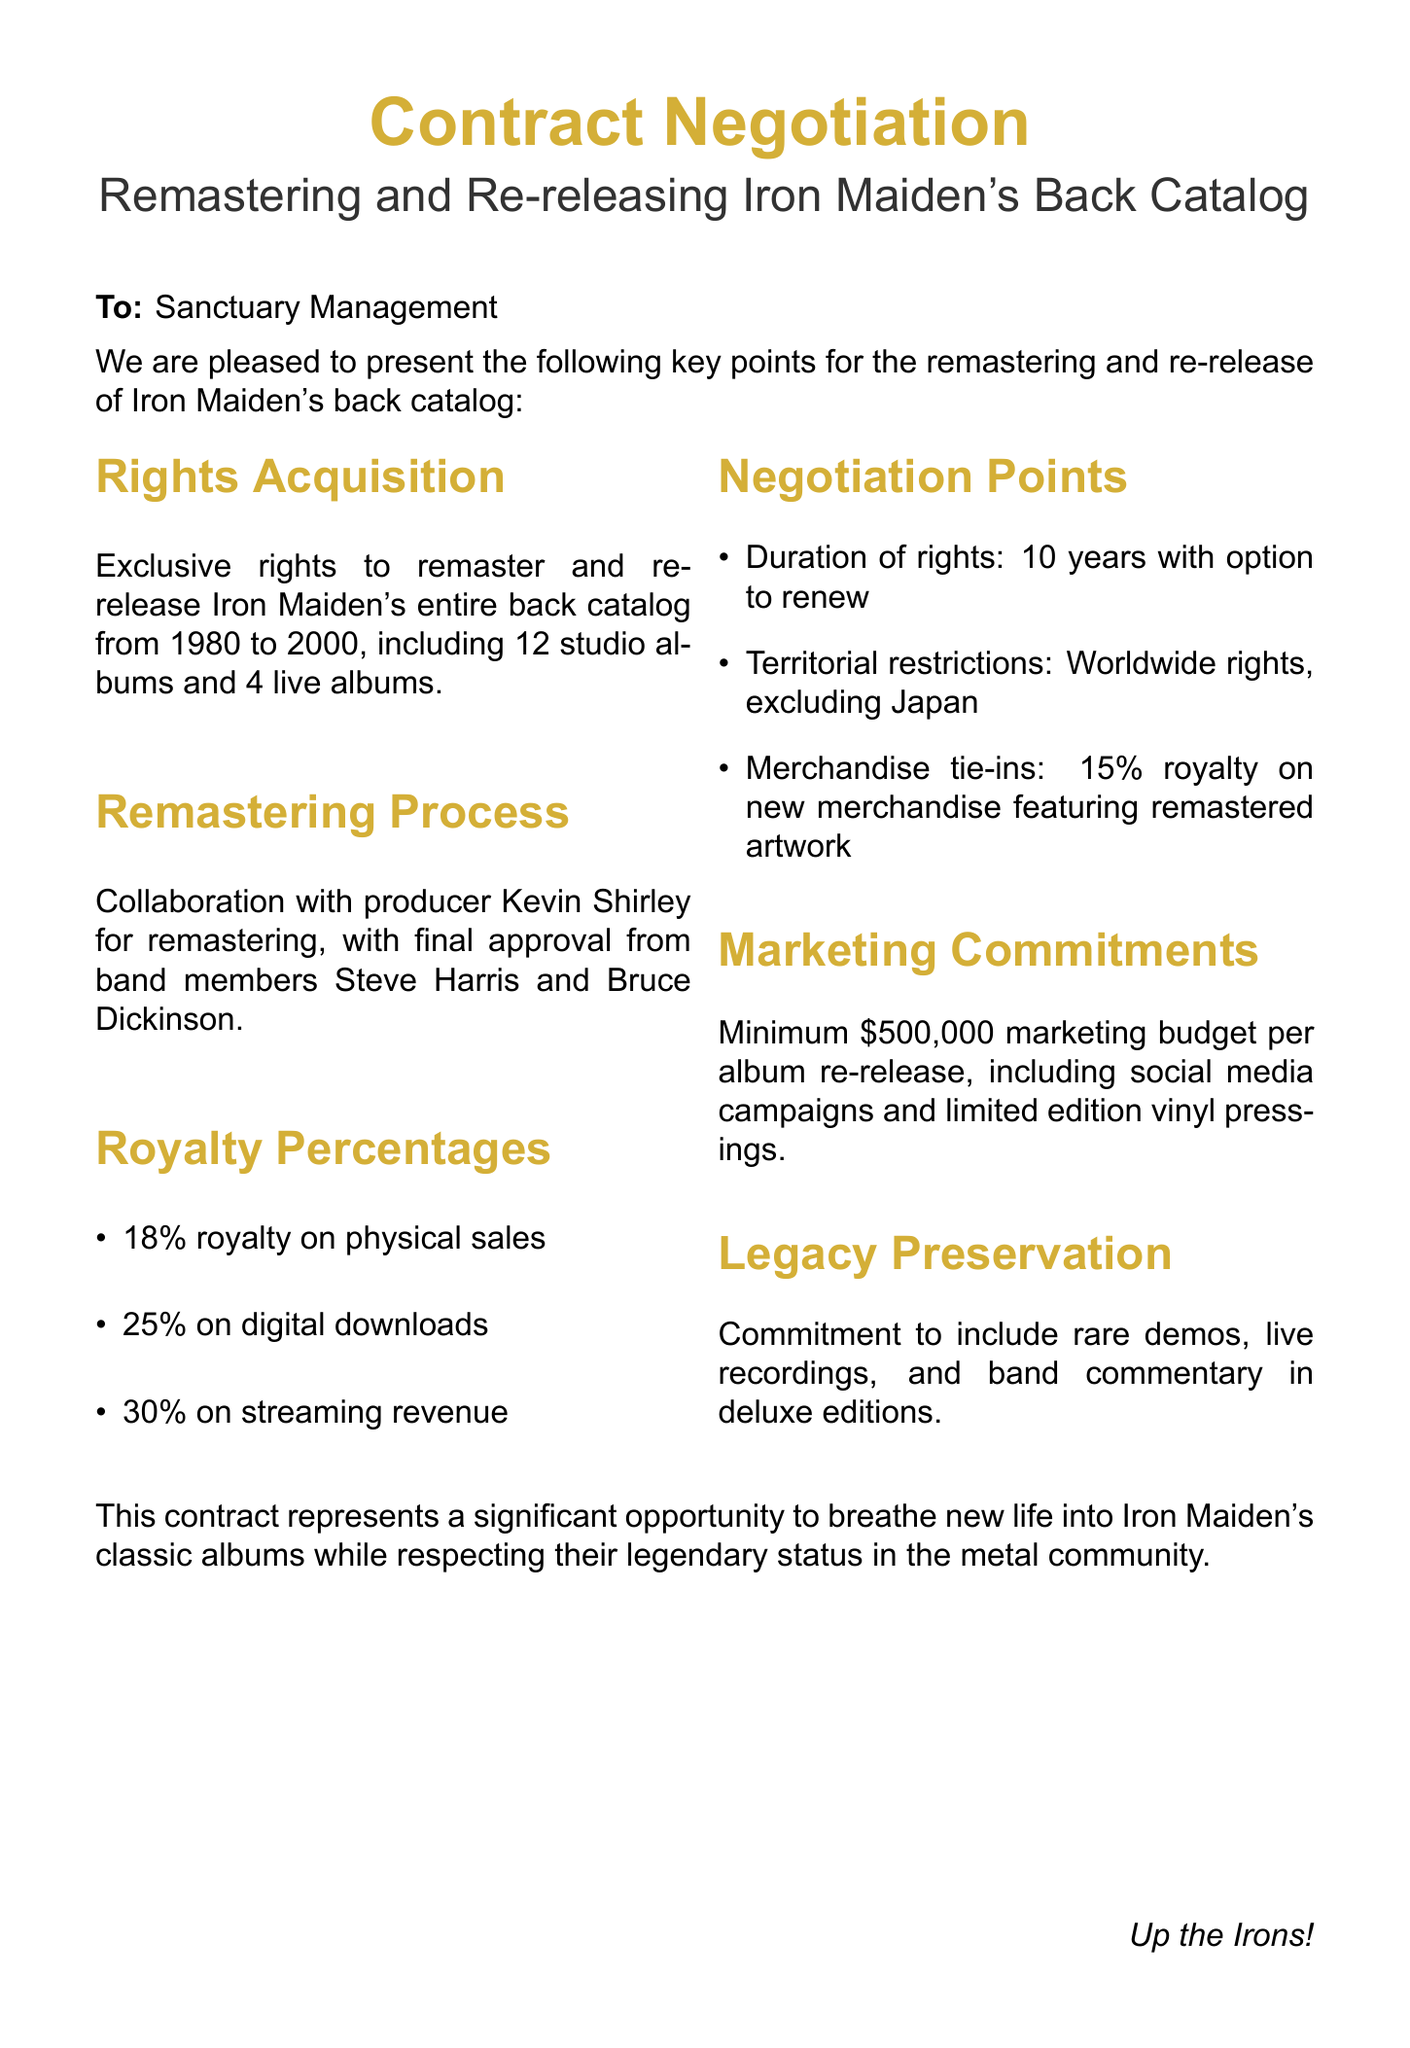What is the band name? The document specifies the band being discussed for rights acquisition.
Answer: Iron Maiden Who is the management company? The management company responsible for handling the contract is mentioned in the document.
Answer: Sanctuary Management How many studio albums are included? The document indicates the number of studio albums in the back catalog available for remastering.
Answer: 12 What is the royalty percentage on digital downloads? The royalty rates for different sales formats are outlined in the contract.
Answer: 25% What is the marketing budget per album re-release? The document specifies the minimum budget allocated for marketing each album re-release.
Answer: $500,000 What is the duration of rights according to the negotiation points? The duration of the rights to the music catalog is mentioned as part of the negotiation terms.
Answer: 10 years Are there any territorial restrictions? The document outlines the territorial limitations regarding the rights acquisition.
Answer: Excluding Japan What is the commitment regarding deluxe editions? The document mentions specific content that should be included in deluxe editions.
Answer: Rare demos, live recordings, and band commentary What is the merchandise royalty percentage? The document specifies the percentage of royalties related to new merchandise.
Answer: 15% 